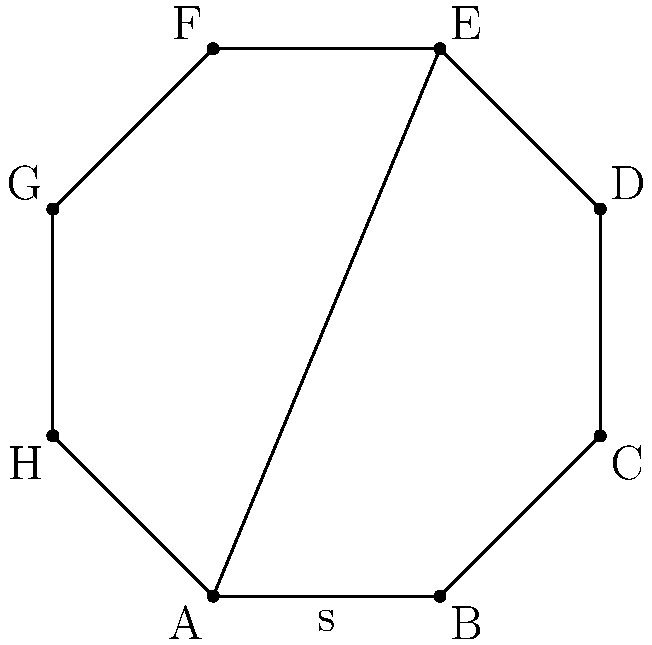As a coder working on a geometry-related plug-in, you need to implement a function to calculate the perimeter of a regular octagon. Given that the length of one side of the regular octagon is $s$, write an expression to determine its perimeter. To find the perimeter of a regular octagon, we can follow these steps:

1. Understand the properties of a regular octagon:
   - It has 8 equal sides
   - All interior angles are equal

2. Recall the formula for perimeter:
   - Perimeter = sum of all sides

3. For a regular octagon with side length $s$:
   - Each side has length $s$
   - There are 8 sides in total

4. Calculate the perimeter:
   - Perimeter = 8 * $s$

Therefore, the expression for the perimeter of a regular octagon with side length $s$ is $8s$.
Answer: $8s$ 